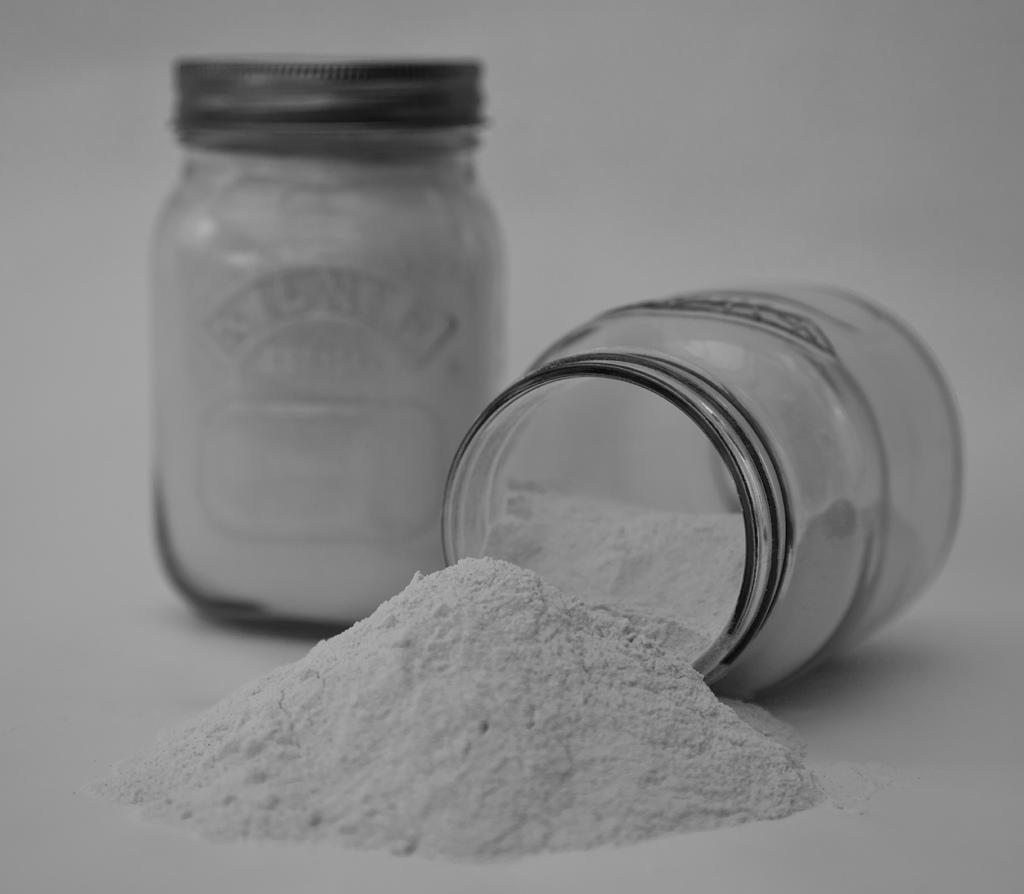What is contained within the container in the image? There is power in a container in the image. What color is the background of the image? The background of the image is white. How many islands can be seen in the image? There are no islands present in the image. What type of plate is used to serve the power in the image? There is no plate present in the image; the power is contained within a container. 